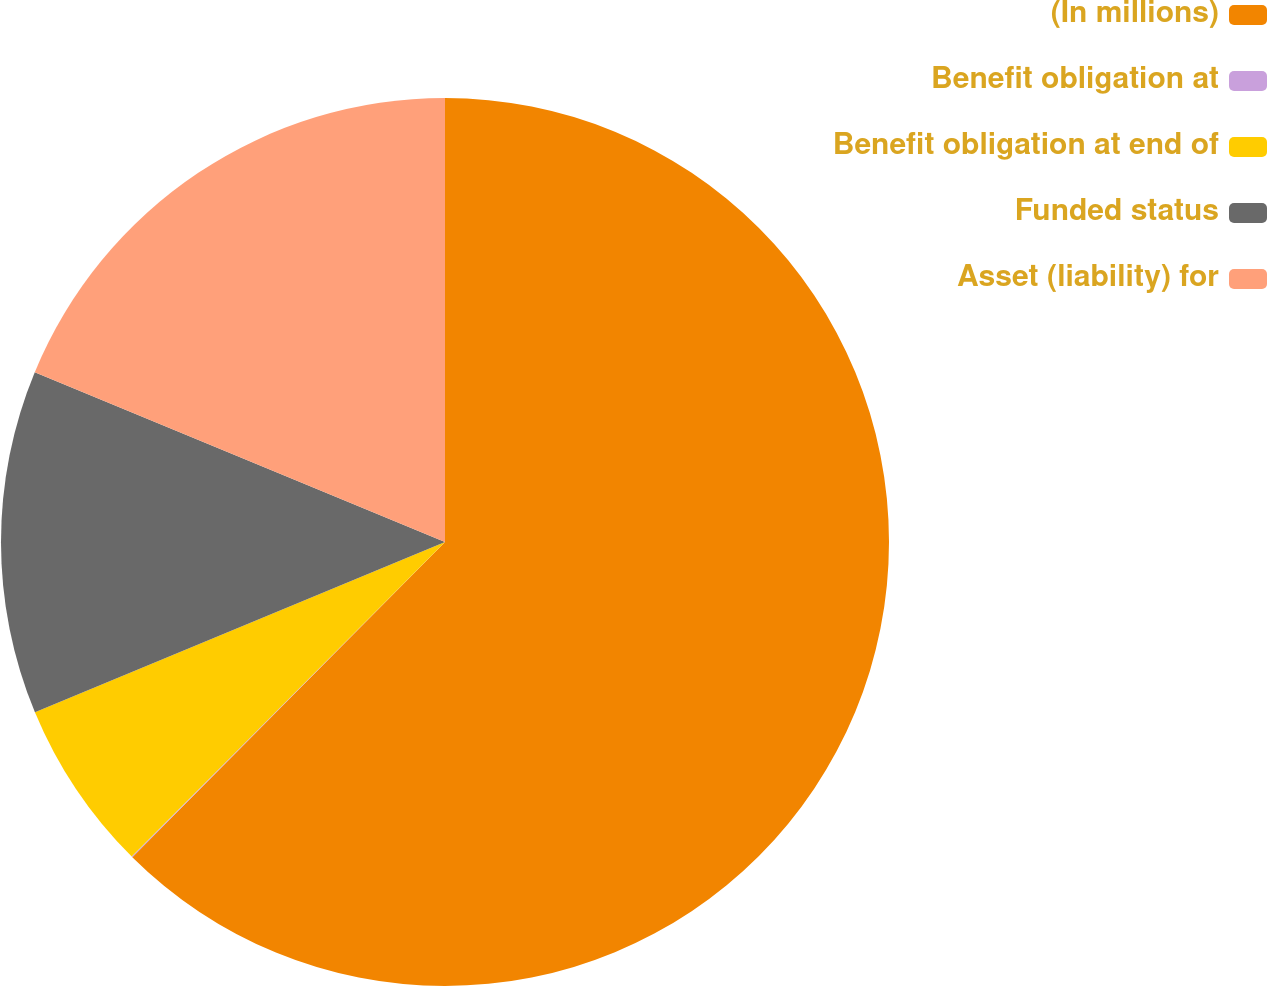Convert chart. <chart><loc_0><loc_0><loc_500><loc_500><pie_chart><fcel>(In millions)<fcel>Benefit obligation at<fcel>Benefit obligation at end of<fcel>Funded status<fcel>Asset (liability) for<nl><fcel>62.43%<fcel>0.03%<fcel>6.27%<fcel>12.51%<fcel>18.75%<nl></chart> 